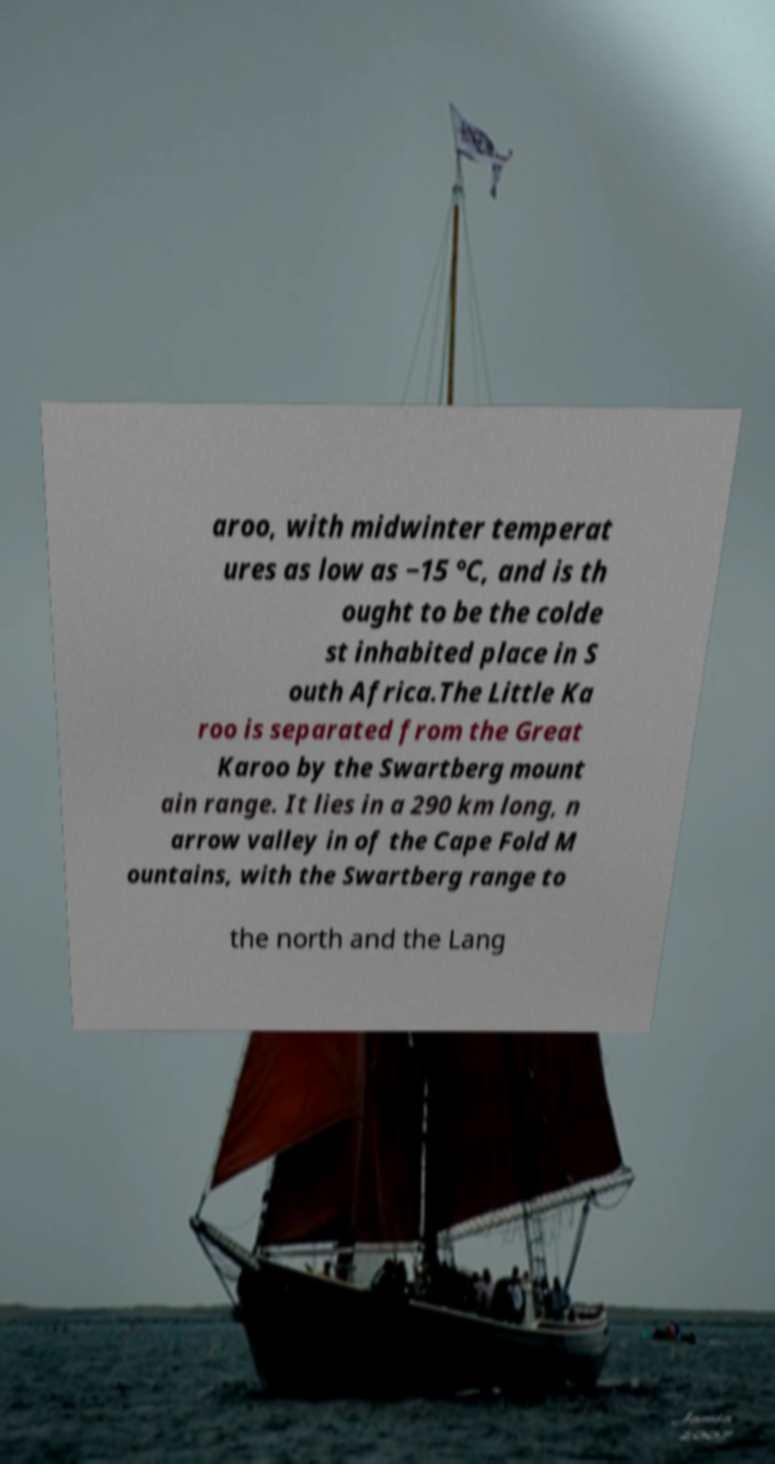What messages or text are displayed in this image? I need them in a readable, typed format. aroo, with midwinter temperat ures as low as −15 °C, and is th ought to be the colde st inhabited place in S outh Africa.The Little Ka roo is separated from the Great Karoo by the Swartberg mount ain range. It lies in a 290 km long, n arrow valley in of the Cape Fold M ountains, with the Swartberg range to the north and the Lang 